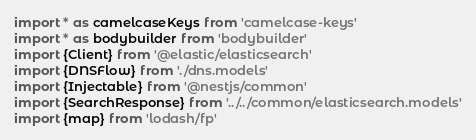Convert code to text. <code><loc_0><loc_0><loc_500><loc_500><_TypeScript_>import * as camelcaseKeys from 'camelcase-keys'
import * as bodybuilder from 'bodybuilder'
import {Client} from '@elastic/elasticsearch'
import {DNSFlow} from './dns.models'
import {Injectable} from '@nestjs/common'
import {SearchResponse} from '../../common/elasticsearch.models'
import {map} from 'lodash/fp'
</code> 